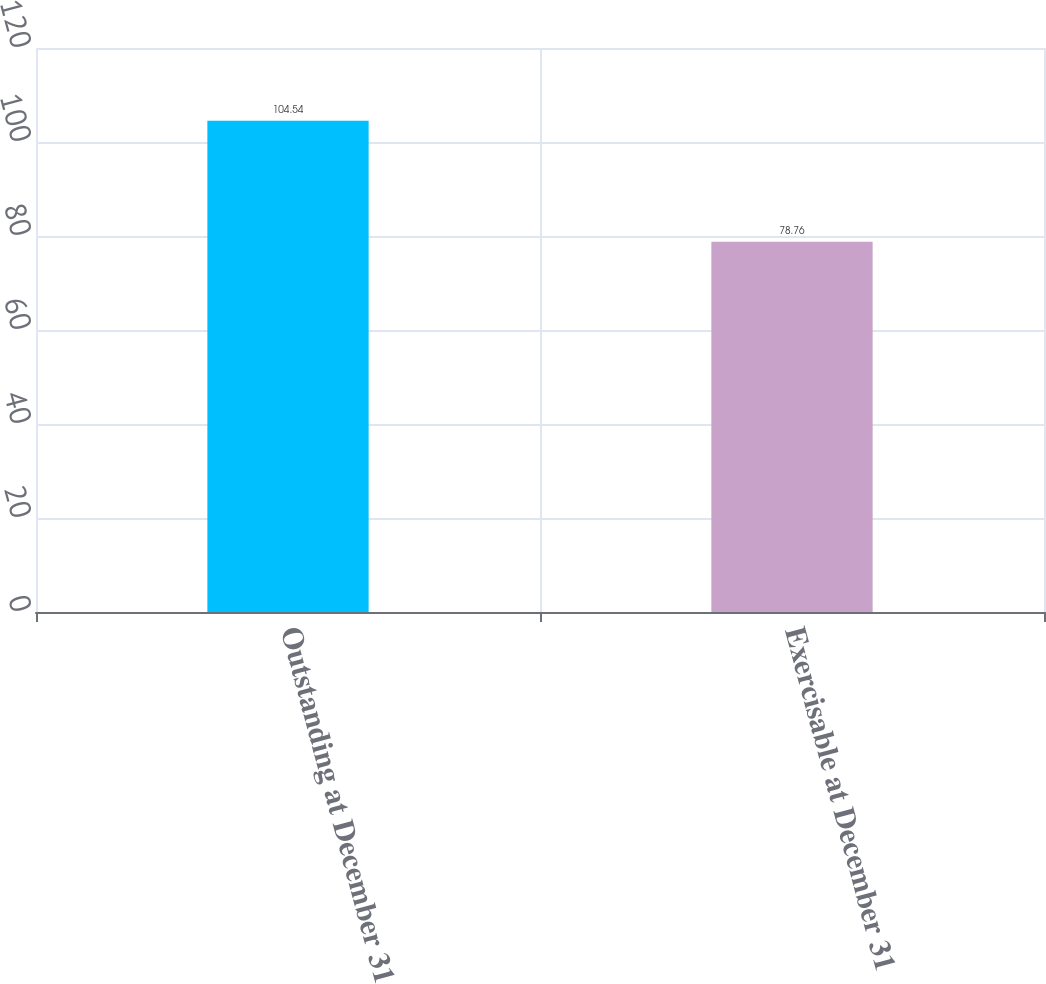<chart> <loc_0><loc_0><loc_500><loc_500><bar_chart><fcel>Outstanding at December 31<fcel>Exercisable at December 31<nl><fcel>104.54<fcel>78.76<nl></chart> 